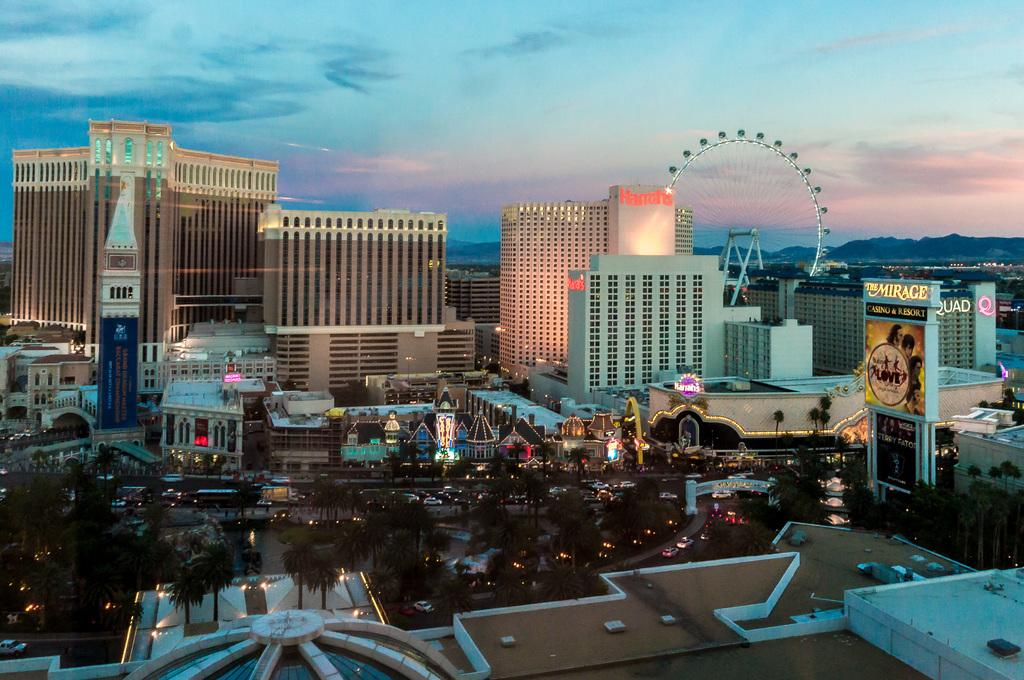What type of structures can be seen in the image? There are buildings in the image. What natural elements are present in the image? There are trees and mountains in the image. What man-made objects can be seen in the image? There are vehicles in the image. What is the condition of the sky in the image? The sky is cloudy in the image. What is written on the board in the image? There is a board with text on the right side of the image. What is the weight of the truck in the image? There is no truck present in the image, so it is not possible to determine its weight. What time of day is it in the image, considering the cloudy sky? The time of day cannot be determined solely from the cloudy sky; additional context or information would be needed. 